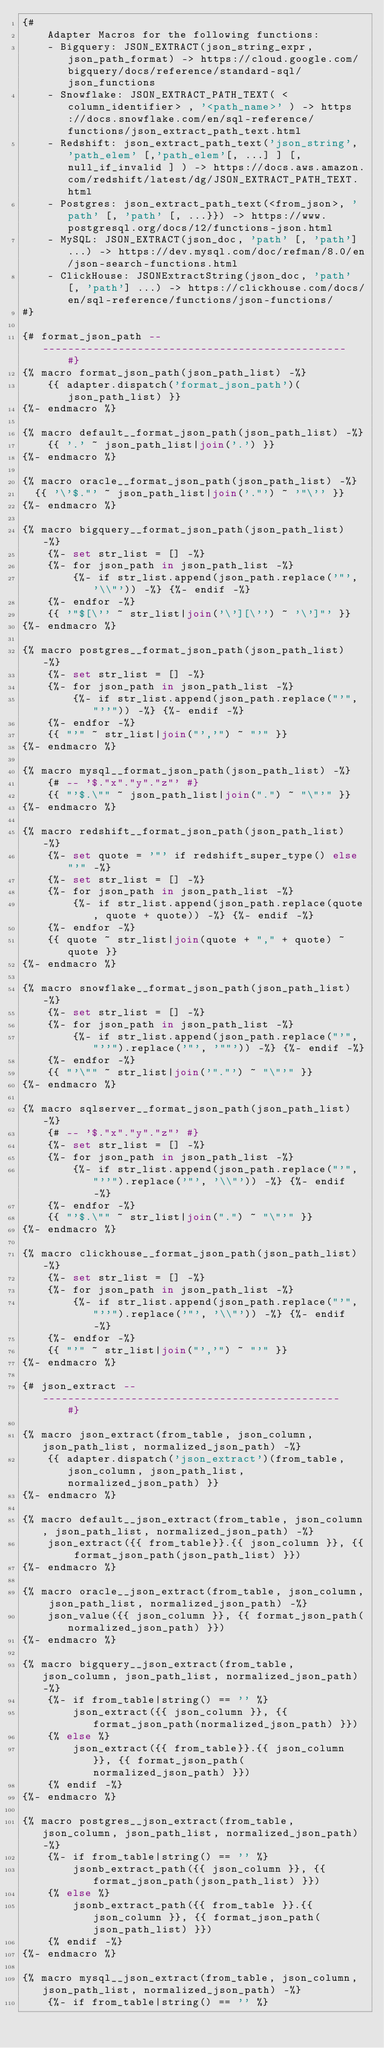<code> <loc_0><loc_0><loc_500><loc_500><_SQL_>{#
    Adapter Macros for the following functions:
    - Bigquery: JSON_EXTRACT(json_string_expr, json_path_format) -> https://cloud.google.com/bigquery/docs/reference/standard-sql/json_functions
    - Snowflake: JSON_EXTRACT_PATH_TEXT( <column_identifier> , '<path_name>' ) -> https://docs.snowflake.com/en/sql-reference/functions/json_extract_path_text.html
    - Redshift: json_extract_path_text('json_string', 'path_elem' [,'path_elem'[, ...] ] [, null_if_invalid ] ) -> https://docs.aws.amazon.com/redshift/latest/dg/JSON_EXTRACT_PATH_TEXT.html
    - Postgres: json_extract_path_text(<from_json>, 'path' [, 'path' [, ...}}) -> https://www.postgresql.org/docs/12/functions-json.html
    - MySQL: JSON_EXTRACT(json_doc, 'path' [, 'path'] ...) -> https://dev.mysql.com/doc/refman/8.0/en/json-search-functions.html
    - ClickHouse: JSONExtractString(json_doc, 'path' [, 'path'] ...) -> https://clickhouse.com/docs/en/sql-reference/functions/json-functions/
#}

{# format_json_path --------------------------------------------------     #}
{% macro format_json_path(json_path_list) -%}
    {{ adapter.dispatch('format_json_path')(json_path_list) }}
{%- endmacro %}

{% macro default__format_json_path(json_path_list) -%}
    {{ '.' ~ json_path_list|join('.') }}
{%- endmacro %}

{% macro oracle__format_json_path(json_path_list) -%}
  {{ '\'$."' ~ json_path_list|join('."') ~ '"\'' }}
{%- endmacro %}

{% macro bigquery__format_json_path(json_path_list) -%}
    {%- set str_list = [] -%}
    {%- for json_path in json_path_list -%}
        {%- if str_list.append(json_path.replace('"', '\\"')) -%} {%- endif -%}
    {%- endfor -%}
    {{ '"$[\'' ~ str_list|join('\'][\'') ~ '\']"' }}
{%- endmacro %}

{% macro postgres__format_json_path(json_path_list) -%}
    {%- set str_list = [] -%}
    {%- for json_path in json_path_list -%}
        {%- if str_list.append(json_path.replace("'", "''")) -%} {%- endif -%}
    {%- endfor -%}
    {{ "'" ~ str_list|join("','") ~ "'" }}
{%- endmacro %}

{% macro mysql__format_json_path(json_path_list) -%}
    {# -- '$."x"."y"."z"' #}
    {{ "'$.\"" ~ json_path_list|join(".") ~ "\"'" }}
{%- endmacro %}

{% macro redshift__format_json_path(json_path_list) -%}
    {%- set quote = '"' if redshift_super_type() else "'" -%}
    {%- set str_list = [] -%}
    {%- for json_path in json_path_list -%}
        {%- if str_list.append(json_path.replace(quote, quote + quote)) -%} {%- endif -%}
    {%- endfor -%}
    {{ quote ~ str_list|join(quote + "," + quote) ~ quote }}
{%- endmacro %}

{% macro snowflake__format_json_path(json_path_list) -%}
    {%- set str_list = [] -%}
    {%- for json_path in json_path_list -%}
        {%- if str_list.append(json_path.replace("'", "''").replace('"', '""')) -%} {%- endif -%}
    {%- endfor -%}
    {{ "'\"" ~ str_list|join('"."') ~ "\"'" }}
{%- endmacro %}

{% macro sqlserver__format_json_path(json_path_list) -%}
    {# -- '$."x"."y"."z"' #}
    {%- set str_list = [] -%}
    {%- for json_path in json_path_list -%}
        {%- if str_list.append(json_path.replace("'", "''").replace('"', '\\"')) -%} {%- endif -%}
    {%- endfor -%}
    {{ "'$.\"" ~ str_list|join(".") ~ "\"'" }}
{%- endmacro %}

{% macro clickhouse__format_json_path(json_path_list) -%}
    {%- set str_list = [] -%}
    {%- for json_path in json_path_list -%}
        {%- if str_list.append(json_path.replace("'", "''").replace('"', '\\"')) -%} {%- endif -%}
    {%- endfor -%}
    {{ "'" ~ str_list|join("','") ~ "'" }}
{%- endmacro %}

{# json_extract -------------------------------------------------     #}

{% macro json_extract(from_table, json_column, json_path_list, normalized_json_path) -%}
    {{ adapter.dispatch('json_extract')(from_table, json_column, json_path_list, normalized_json_path) }}
{%- endmacro %}

{% macro default__json_extract(from_table, json_column, json_path_list, normalized_json_path) -%}
    json_extract({{ from_table}}.{{ json_column }}, {{ format_json_path(json_path_list) }})
{%- endmacro %}

{% macro oracle__json_extract(from_table, json_column, json_path_list, normalized_json_path) -%}
    json_value({{ json_column }}, {{ format_json_path(normalized_json_path) }})
{%- endmacro %}

{% macro bigquery__json_extract(from_table, json_column, json_path_list, normalized_json_path) -%}
    {%- if from_table|string() == '' %}
        json_extract({{ json_column }}, {{ format_json_path(normalized_json_path) }})
    {% else %}
        json_extract({{ from_table}}.{{ json_column }}, {{ format_json_path(normalized_json_path) }})
    {% endif -%}
{%- endmacro %}

{% macro postgres__json_extract(from_table, json_column, json_path_list, normalized_json_path) -%}
    {%- if from_table|string() == '' %}
        jsonb_extract_path({{ json_column }}, {{ format_json_path(json_path_list) }})
    {% else %}
        jsonb_extract_path({{ from_table }}.{{ json_column }}, {{ format_json_path(json_path_list) }})
    {% endif -%}
{%- endmacro %}

{% macro mysql__json_extract(from_table, json_column, json_path_list, normalized_json_path) -%}
    {%- if from_table|string() == '' %}</code> 